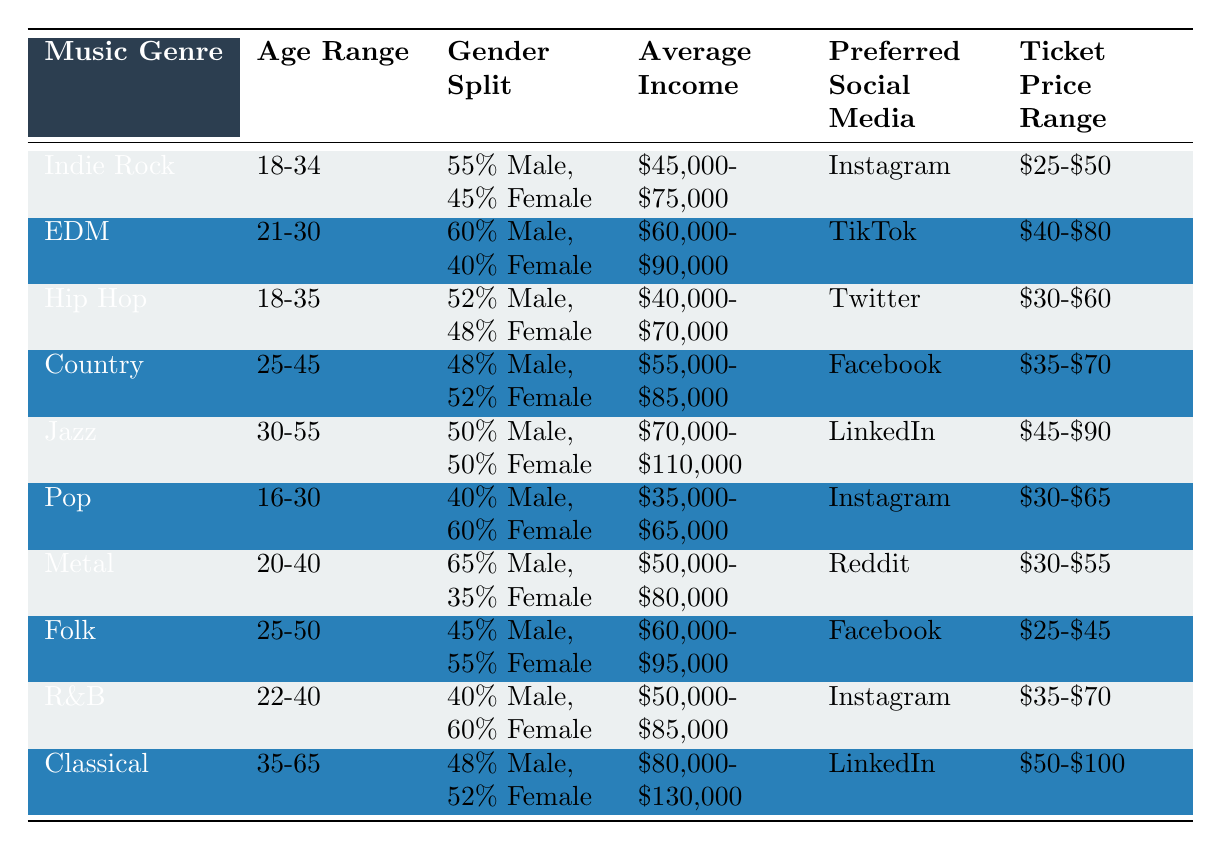What is the average income for Indie Rock fans? The table shows that the average income for Indie Rock fans is between $45,000 and $75,000. Therefore, the average can be estimated as the midpoint, which is ($45,000 + $75,000) / 2 = $60,000.
Answer: $60,000 Which genre has the highest percentage of male audience? By examining the gender split for each genre, Metal has the highest percentage of male audience at 65%.
Answer: 65% Is the average ticket price range for Jazz higher than that for Country? The average ticket price range for Jazz is $45-$90, and for Country, it is $35-$70. Since $45 is greater than $35, and $90 is greater than $70, the average ticket price range for Jazz is indeed higher.
Answer: Yes What is the preferred social media platform for the Pop genre? According to the table, the preferred social media platform for Pop is Instagram.
Answer: Instagram What is the age range of the EDM audience? The table indicates that the age range for EDM fans is 21-30.
Answer: 21-30 How does the average income for Folk compare to that of Classical? Folk has an average income range of $60,000-$95,000, while Classical has $80,000-$130,000. The average for Folk is around $77,500 and for Classical it is $105,000. $77,500 is less than $105,000, so Folk has a lower average income compared to Classical.
Answer: Lower Which genre has the lowest ticket price range? The table shows that Folk has the lowest ticket price range at $25-$45.
Answer: $25-$45 Are there more Female fans than Male fans in the Country genre? In the Country genre, the gender split is 48% male and 52% female, indicating that there are indeed more Female fans than Male fans.
Answer: Yes What is the average income for the audiences of genres with the highest female representation? The genres with the highest female representation are Pop (60% Female) and R&B (60% Female). The average income for Pop is $35,000-$65,000, which averages to $50,000, while R&B has $50,000-$85,000, averaging to $67,500. The average of $50,000 and $67,500 is ($50,000 + $67,500) / 2 = $58,750.
Answer: $58,750 Do most genres have a ticket price range above $40? The ticket price ranges for genres are: Indie Rock ($25-$50), EDM ($40-$80), Hip Hop ($30-$60), Country ($35-$70), Jazz ($45-$90), Pop ($30-$65), Metal ($30-$55), Folk ($25-$45), R&B ($35-$70), and Classical ($50-$100). Only Indie Rock, Hip Hop, Pop, Metal, and Folk have ranges lower than or equal to $40, while the rest are above $40. Since there are 5 out of 10 genres below $40, the answer is no.
Answer: No 